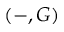Convert formula to latex. <formula><loc_0><loc_0><loc_500><loc_500>( - , G )</formula> 